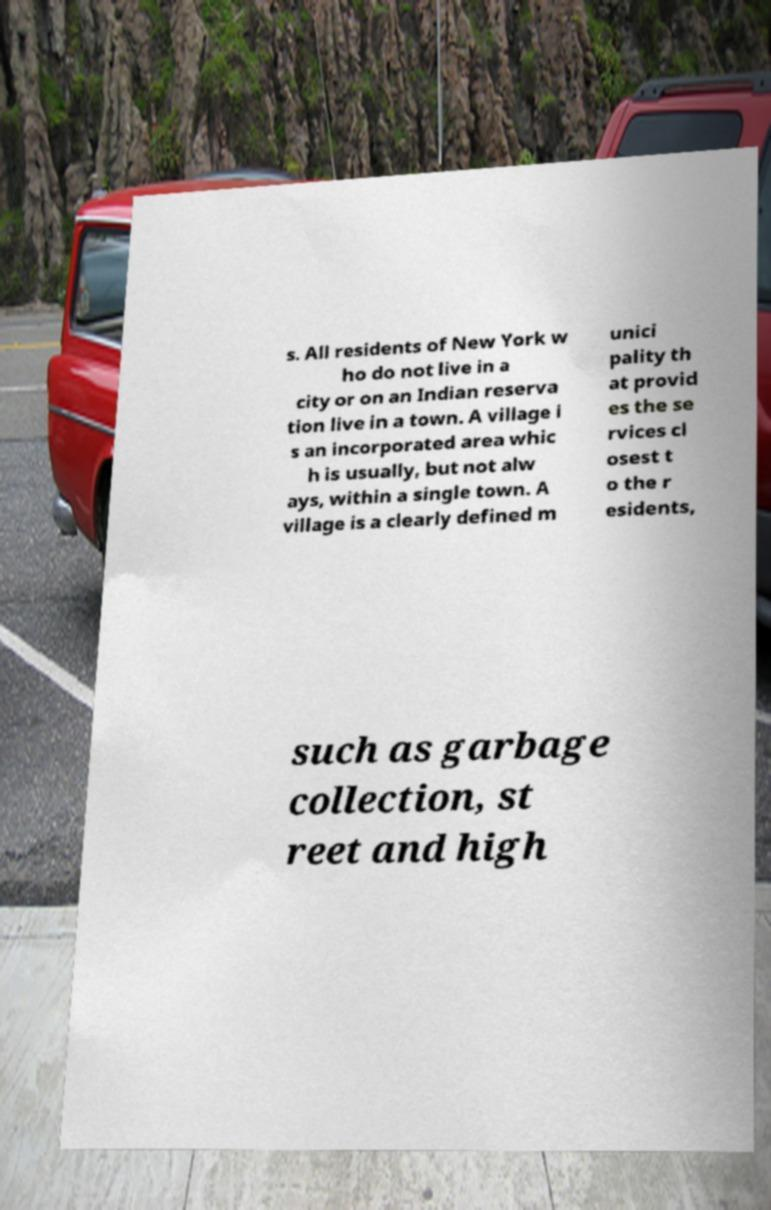There's text embedded in this image that I need extracted. Can you transcribe it verbatim? s. All residents of New York w ho do not live in a city or on an Indian reserva tion live in a town. A village i s an incorporated area whic h is usually, but not alw ays, within a single town. A village is a clearly defined m unici pality th at provid es the se rvices cl osest t o the r esidents, such as garbage collection, st reet and high 